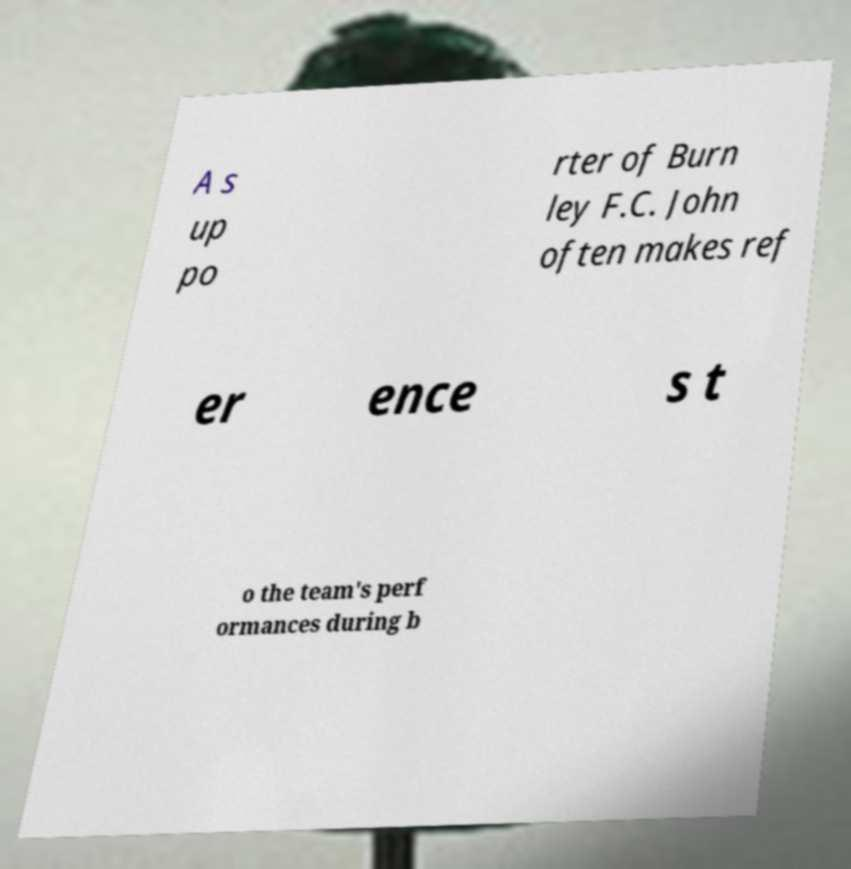Can you read and provide the text displayed in the image?This photo seems to have some interesting text. Can you extract and type it out for me? A s up po rter of Burn ley F.C. John often makes ref er ence s t o the team's perf ormances during b 